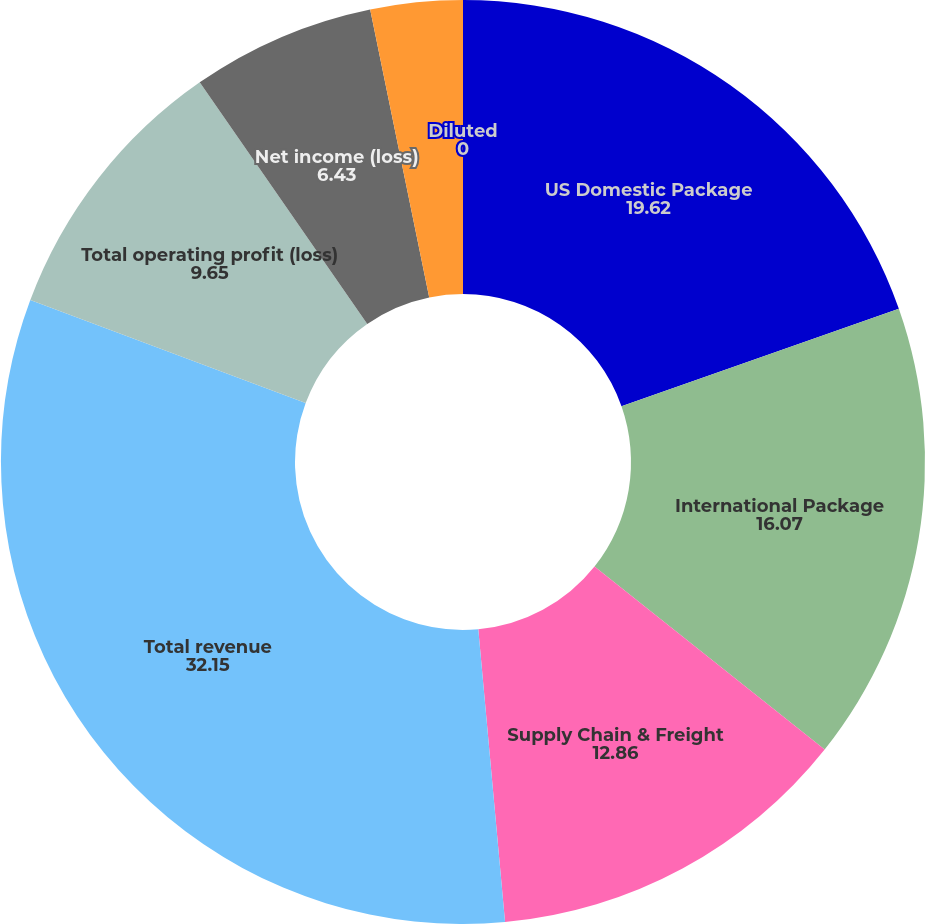Convert chart. <chart><loc_0><loc_0><loc_500><loc_500><pie_chart><fcel>US Domestic Package<fcel>International Package<fcel>Supply Chain & Freight<fcel>Total revenue<fcel>Total operating profit (loss)<fcel>Net income (loss)<fcel>Basic<fcel>Diluted<nl><fcel>19.62%<fcel>16.07%<fcel>12.86%<fcel>32.15%<fcel>9.65%<fcel>6.43%<fcel>3.22%<fcel>0.0%<nl></chart> 